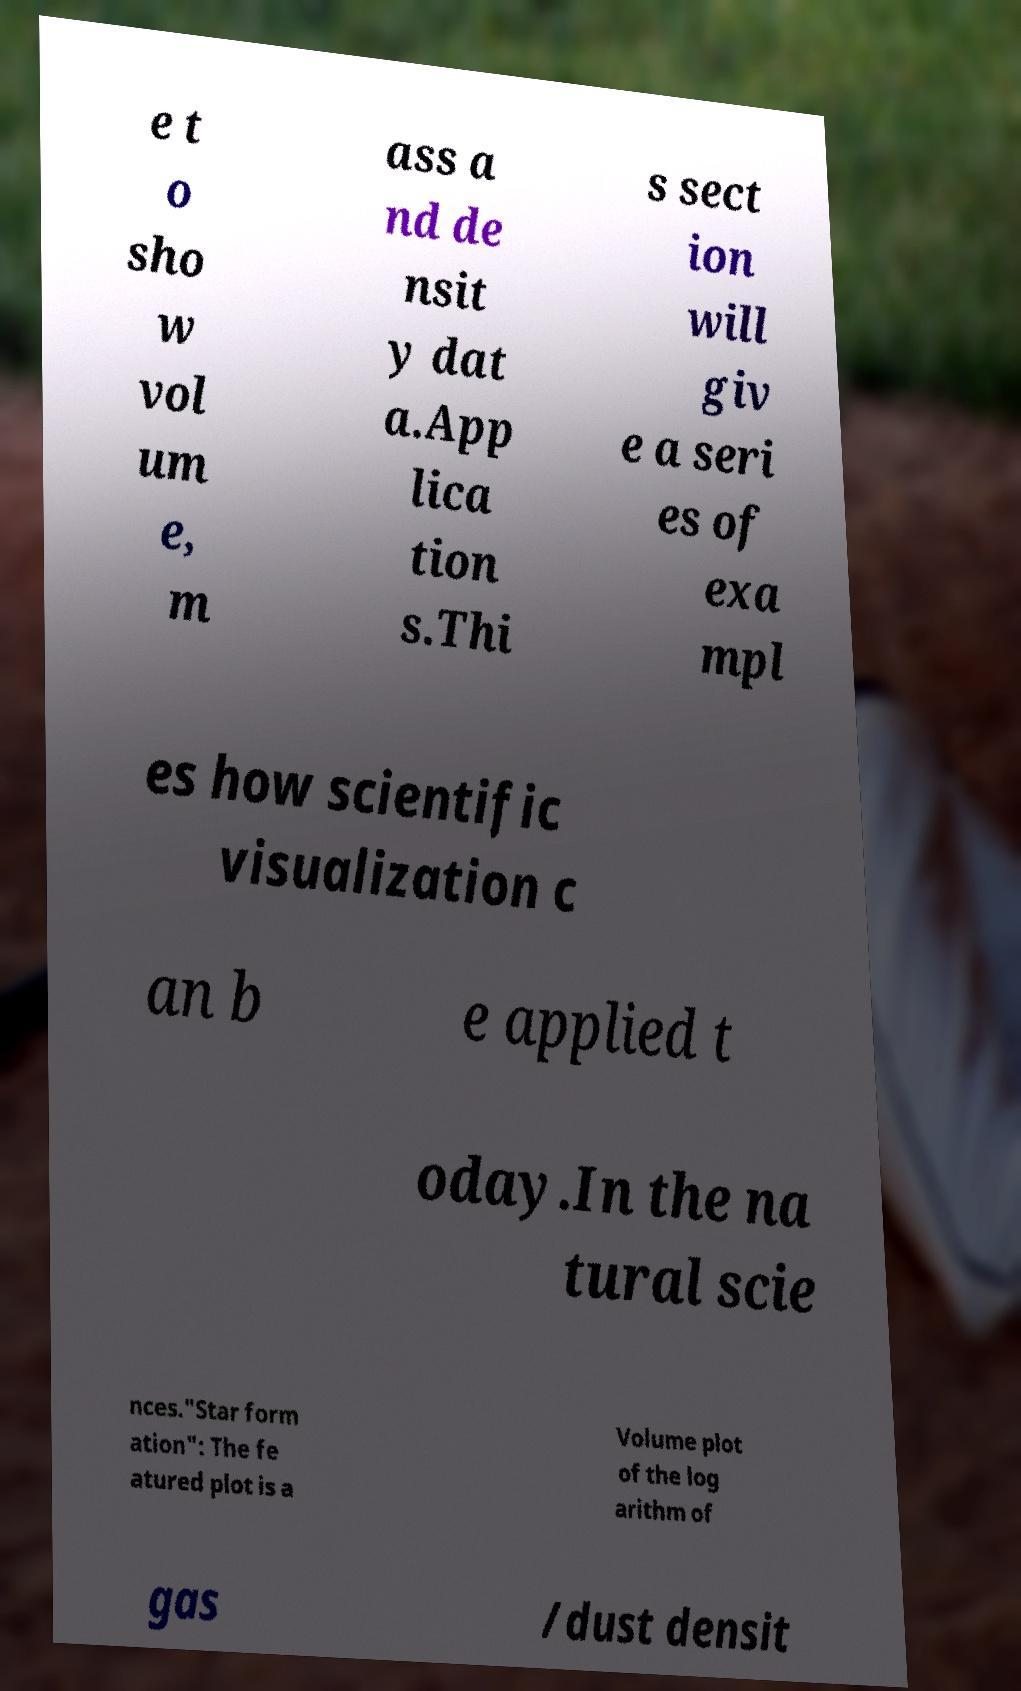Can you read and provide the text displayed in the image?This photo seems to have some interesting text. Can you extract and type it out for me? e t o sho w vol um e, m ass a nd de nsit y dat a.App lica tion s.Thi s sect ion will giv e a seri es of exa mpl es how scientific visualization c an b e applied t oday.In the na tural scie nces."Star form ation": The fe atured plot is a Volume plot of the log arithm of gas /dust densit 